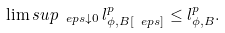<formula> <loc_0><loc_0><loc_500><loc_500>\lim s u p _ { \ e p s \downarrow 0 } \, l ^ { p } _ { \phi , B [ \ e p s ] } \leq l ^ { p } _ { \phi , B } .</formula> 